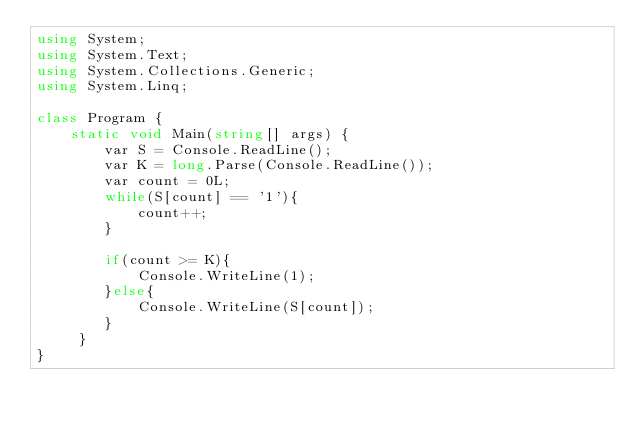<code> <loc_0><loc_0><loc_500><loc_500><_C#_>using System;
using System.Text;
using System.Collections.Generic;
using System.Linq;
 
class Program {
    static void Main(string[] args) {
        var S = Console.ReadLine();
        var K = long.Parse(Console.ReadLine());
        var count = 0L;
        while(S[count] == '1'){
            count++;
        }
        
        if(count >= K){
            Console.WriteLine(1);
        }else{
            Console.WriteLine(S[count]);
        }             
     }
}
</code> 